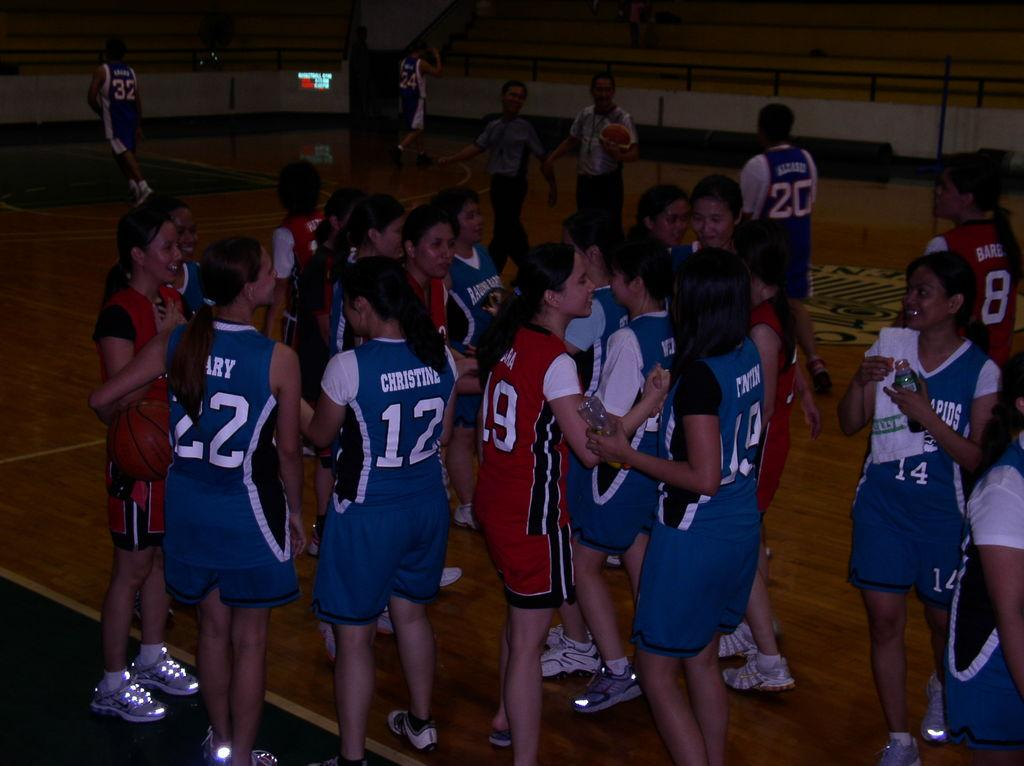<image>
Offer a succinct explanation of the picture presented. Player number 20 is separated from the group of other players and is walking away. 